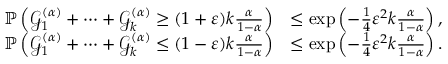Convert formula to latex. <formula><loc_0><loc_0><loc_500><loc_500>\begin{array} { r l } { \mathbb { P } \left ( \mathcal { G } _ { 1 } ^ { ( \alpha ) } + \dots + \mathcal { G } _ { k } ^ { ( \alpha ) } \geq ( 1 + \varepsilon ) k \frac { \alpha } { 1 - \alpha } \right ) } & { \leq \exp \left ( - \frac { 1 } { 4 } \varepsilon ^ { 2 } k \frac { \alpha } { 1 - \alpha } \right ) , } \\ { \mathbb { P } \left ( \mathcal { G } _ { 1 } ^ { ( \alpha ) } + \dots + \mathcal { G } _ { k } ^ { ( \alpha ) } \leq ( 1 - \varepsilon ) k \frac { \alpha } { 1 - \alpha } \right ) } & { \leq \exp \left ( - \frac { 1 } { 4 } \varepsilon ^ { 2 } k \frac { \alpha } { 1 - \alpha } \right ) . } \end{array}</formula> 